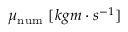Convert formula to latex. <formula><loc_0><loc_0><loc_500><loc_500>\mu _ { n u m } \ [ k g { m } \cdot s ^ { - 1 } ]</formula> 